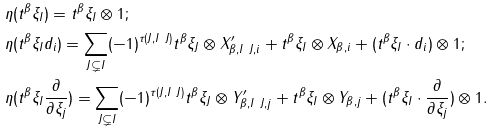Convert formula to latex. <formula><loc_0><loc_0><loc_500><loc_500>& \eta ( t ^ { \beta } \xi _ { I } ) = t ^ { \beta } \xi _ { I } \otimes 1 ; \\ & \eta ( t ^ { \beta } \xi _ { I } d _ { i } ) = \sum _ { J \subsetneq I } ( - 1 ) ^ { \tau ( J , I \ J ) } t ^ { \beta } \xi _ { J } \otimes X ^ { \prime } _ { \beta , I \ J , i } + t ^ { \beta } \xi _ { I } \otimes X _ { \beta , i } + ( t ^ { \beta } \xi _ { I } \cdot d _ { i } ) \otimes 1 ; \\ & \eta ( t ^ { \beta } \xi _ { I } \frac { \partial } { \partial \xi _ { j } } ) = \sum _ { J \subsetneq I } ( - 1 ) ^ { \tau ( J , I \ J ) } t ^ { \beta } \xi _ { J } \otimes Y ^ { \prime } _ { \beta , I \ J , j } + t ^ { \beta } \xi _ { I } \otimes Y _ { \beta , j } + ( t ^ { \beta } \xi _ { I } \cdot \frac { \partial } { \partial \xi _ { j } } ) \otimes 1 .</formula> 